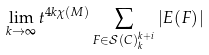<formula> <loc_0><loc_0><loc_500><loc_500>\lim _ { k \rightarrow \infty } t ^ { 4 k \chi ( M ) } \sum _ { F \in \mathcal { S } ( C ) _ { k } ^ { k + i } } | E ( F ) |</formula> 